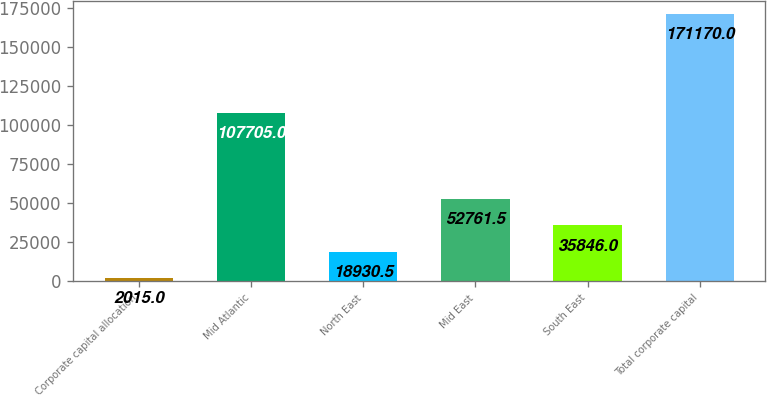Convert chart to OTSL. <chart><loc_0><loc_0><loc_500><loc_500><bar_chart><fcel>Corporate capital allocation<fcel>Mid Atlantic<fcel>North East<fcel>Mid East<fcel>South East<fcel>Total corporate capital<nl><fcel>2015<fcel>107705<fcel>18930.5<fcel>52761.5<fcel>35846<fcel>171170<nl></chart> 